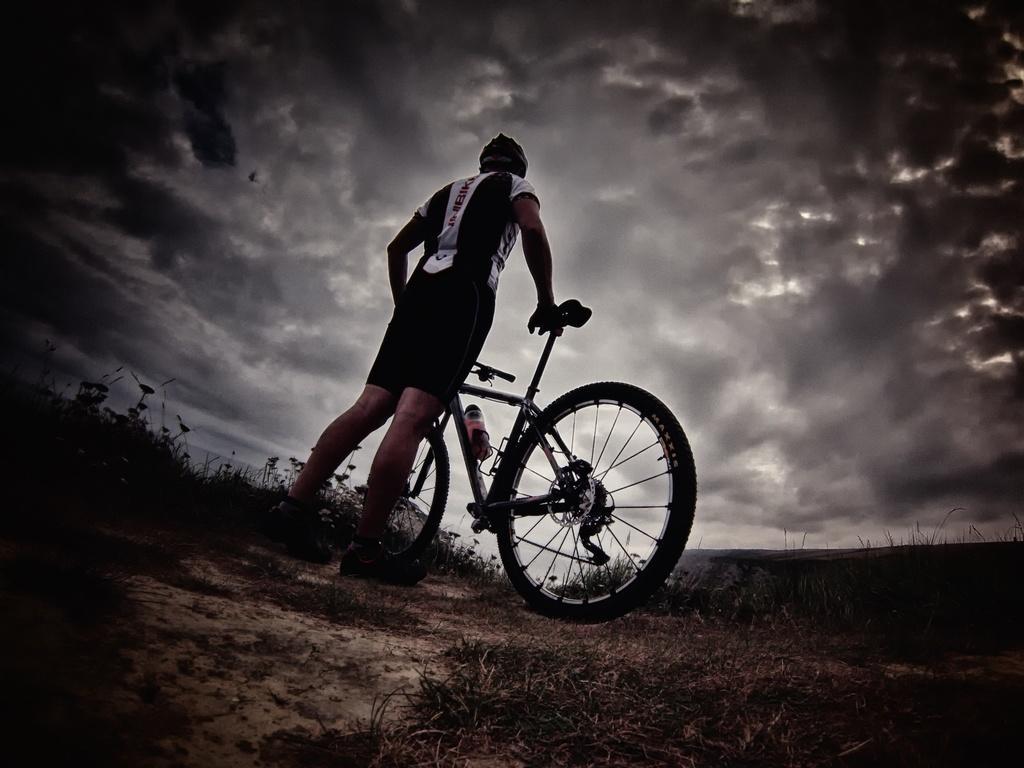Describe this image in one or two sentences. In this image we can see a person with a bicycle and the person is standing on the ground. We can also see the water bottle. In the background there is a cloudy sky and at the bottom we can see the grass. 